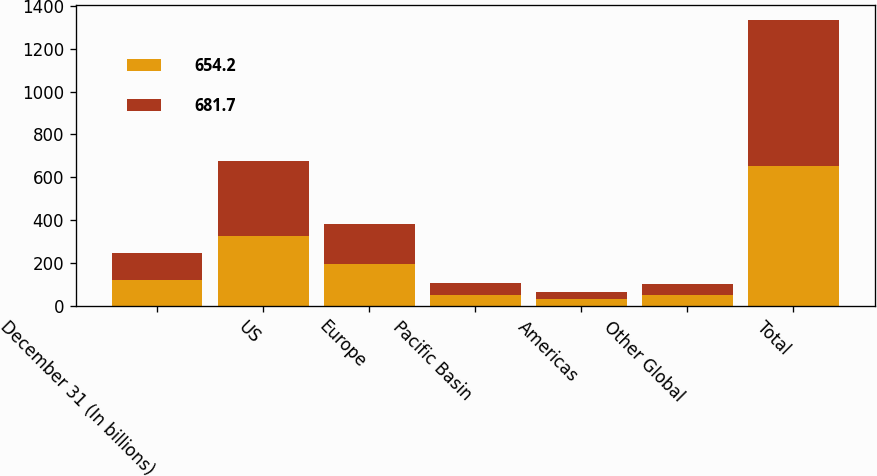<chart> <loc_0><loc_0><loc_500><loc_500><stacked_bar_chart><ecel><fcel>December 31 (In billions)<fcel>US<fcel>Europe<fcel>Pacific Basin<fcel>Americas<fcel>Other Global<fcel>Total<nl><fcel>654.2<fcel>122.3<fcel>325.4<fcel>195.1<fcel>51.8<fcel>32.9<fcel>49<fcel>654.2<nl><fcel>681.7<fcel>122.3<fcel>350.7<fcel>188.9<fcel>55.7<fcel>32.9<fcel>53.5<fcel>681.7<nl></chart> 